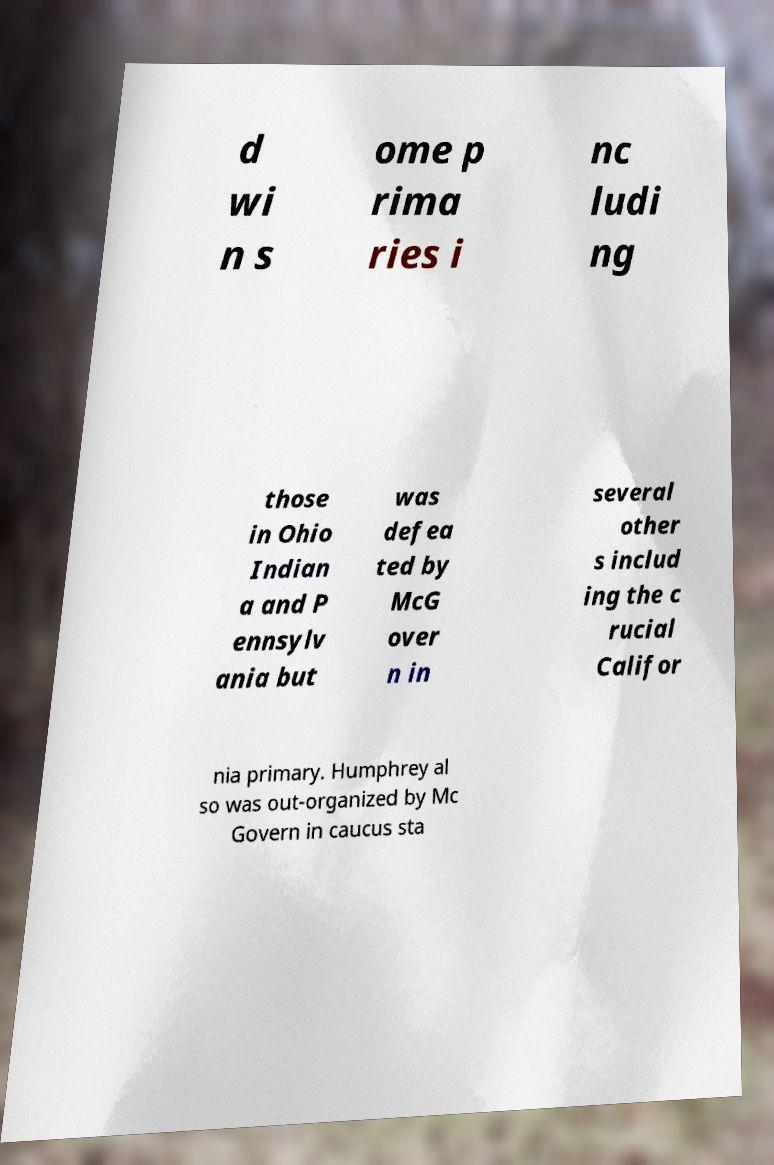Please identify and transcribe the text found in this image. d wi n s ome p rima ries i nc ludi ng those in Ohio Indian a and P ennsylv ania but was defea ted by McG over n in several other s includ ing the c rucial Califor nia primary. Humphrey al so was out-organized by Mc Govern in caucus sta 